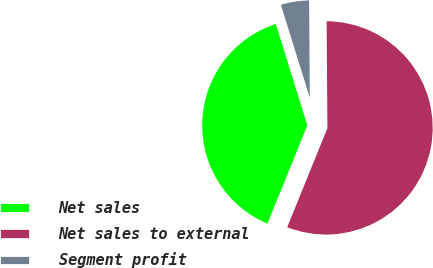Convert chart. <chart><loc_0><loc_0><loc_500><loc_500><pie_chart><fcel>Net sales<fcel>Net sales to external<fcel>Segment profit<nl><fcel>39.06%<fcel>56.25%<fcel>4.69%<nl></chart> 